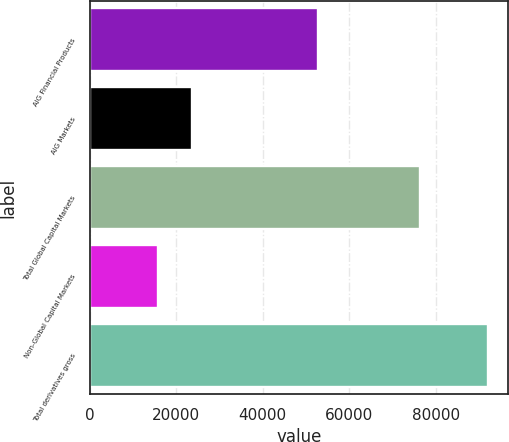Convert chart to OTSL. <chart><loc_0><loc_0><loc_500><loc_500><bar_chart><fcel>AIG Financial Products<fcel>AIG Markets<fcel>Total Global Capital Markets<fcel>Non-Global Capital Markets<fcel>Total derivatives gross<nl><fcel>52679<fcel>23716<fcel>76395<fcel>15668<fcel>92063<nl></chart> 